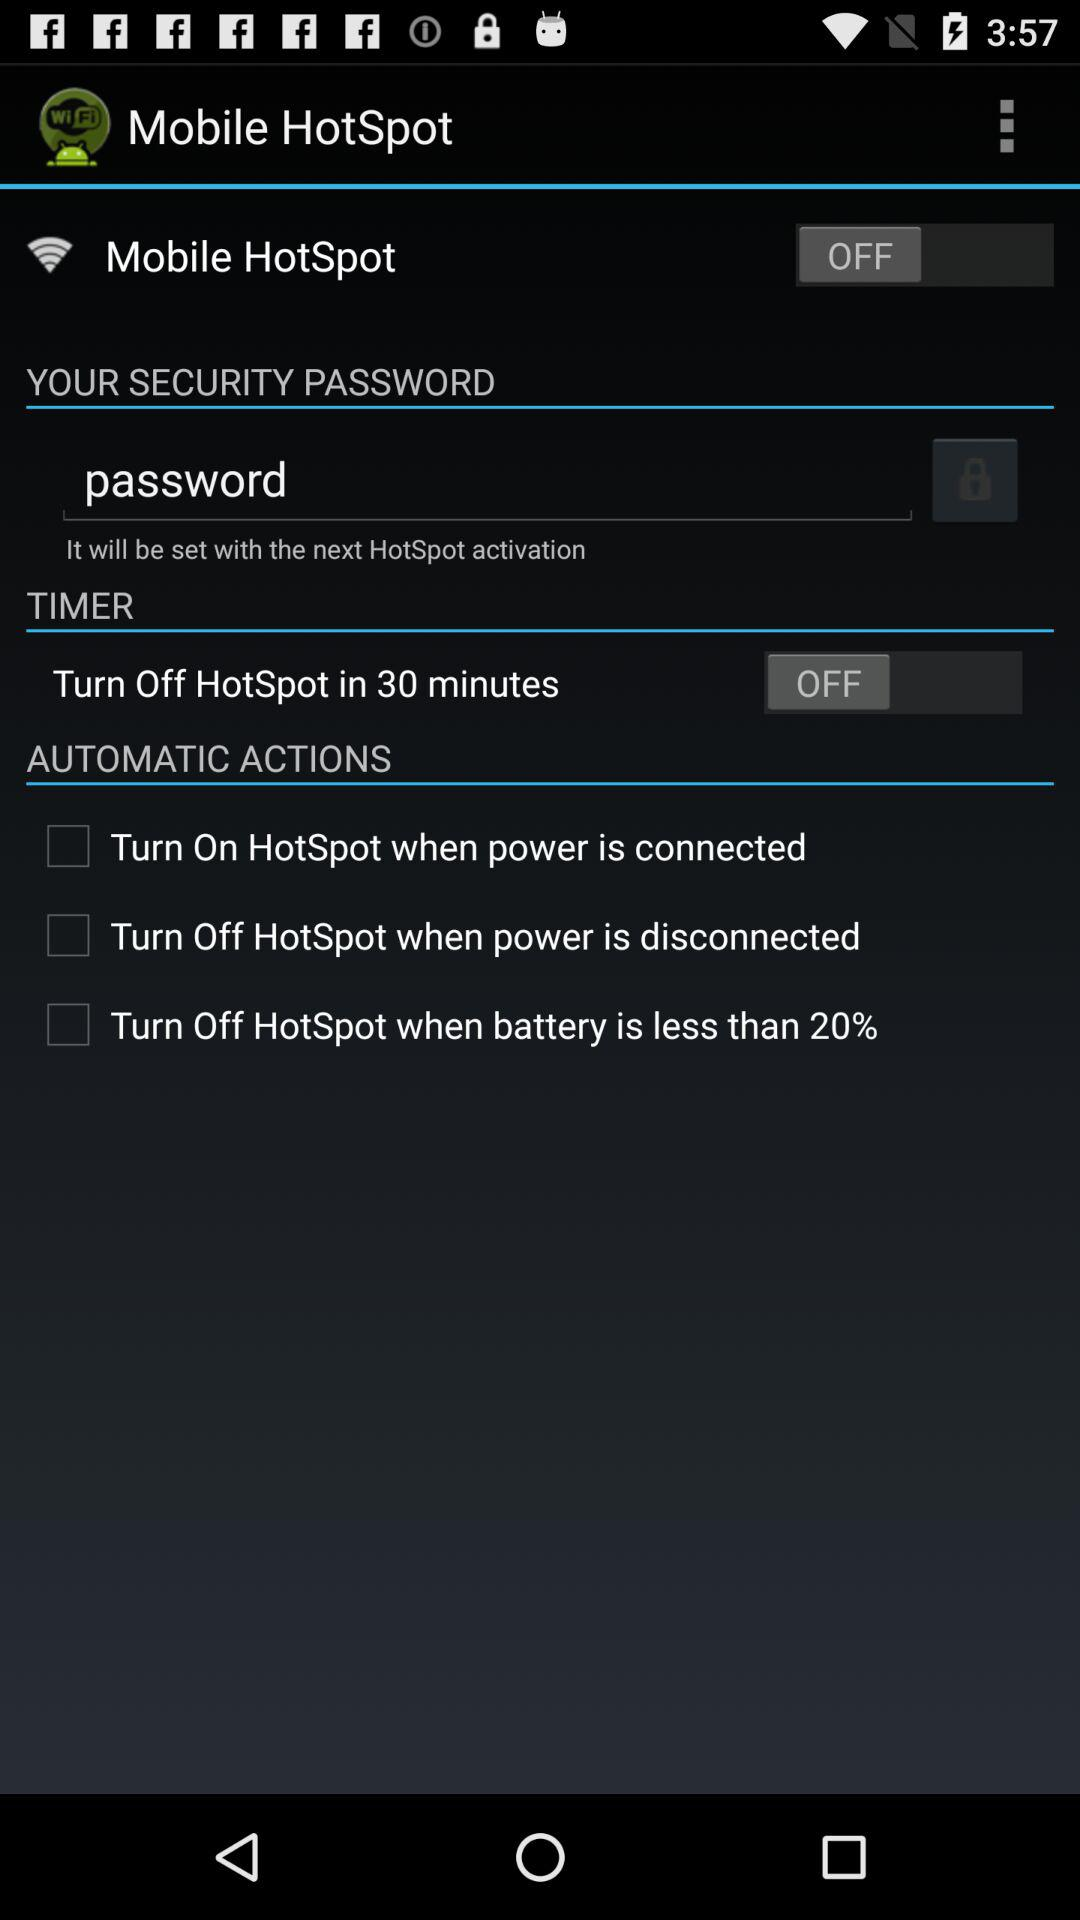What is the status of the mobile hotspot? The status is off. 